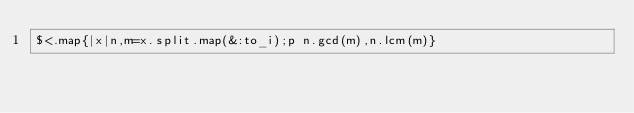Convert code to text. <code><loc_0><loc_0><loc_500><loc_500><_Ruby_>$<.map{|x|n,m=x.split.map(&:to_i);p n.gcd(m),n.lcm(m)}</code> 